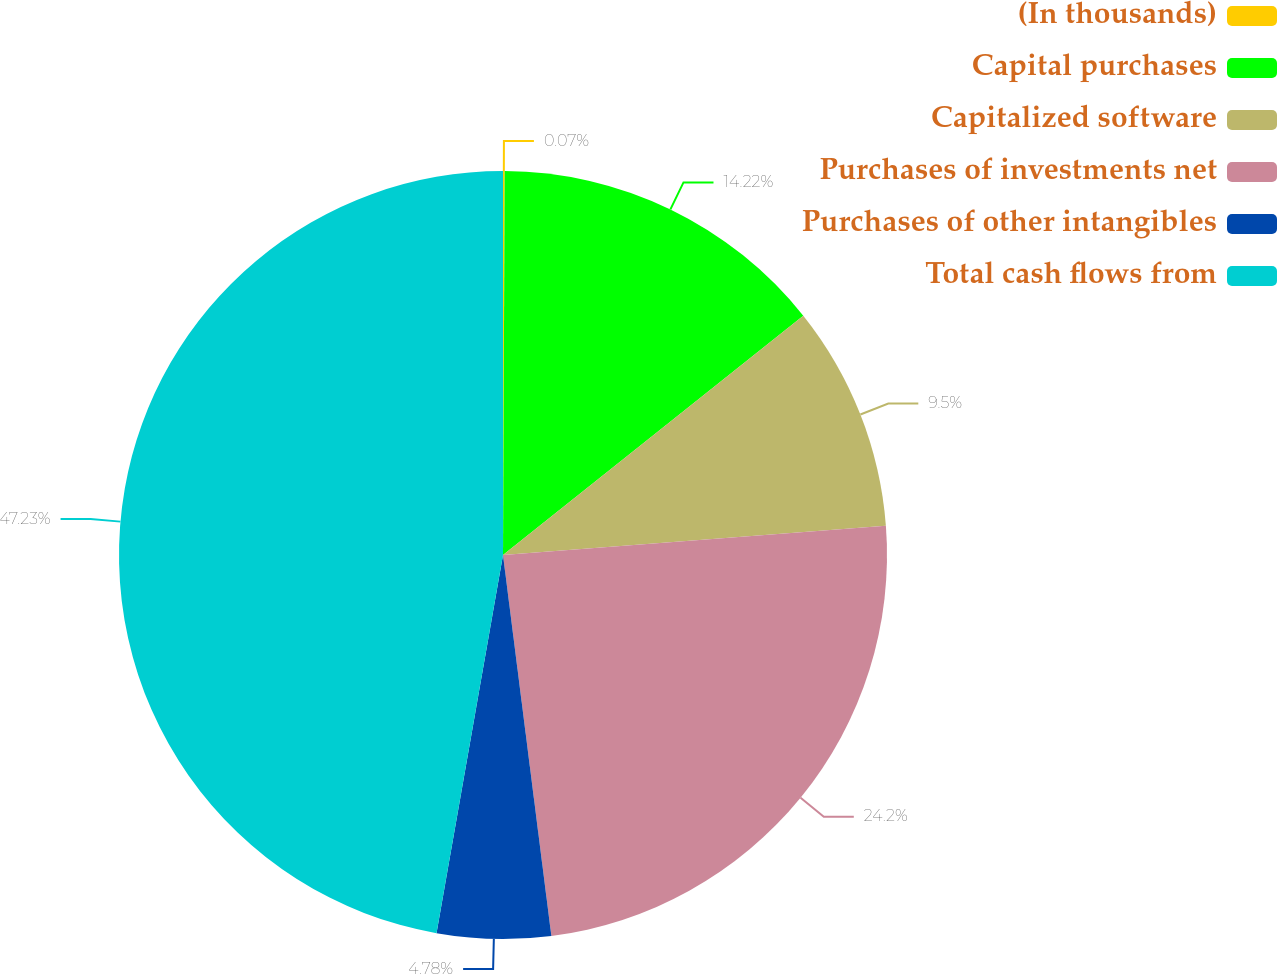Convert chart to OTSL. <chart><loc_0><loc_0><loc_500><loc_500><pie_chart><fcel>(In thousands)<fcel>Capital purchases<fcel>Capitalized software<fcel>Purchases of investments net<fcel>Purchases of other intangibles<fcel>Total cash flows from<nl><fcel>0.07%<fcel>14.22%<fcel>9.5%<fcel>24.2%<fcel>4.78%<fcel>47.23%<nl></chart> 